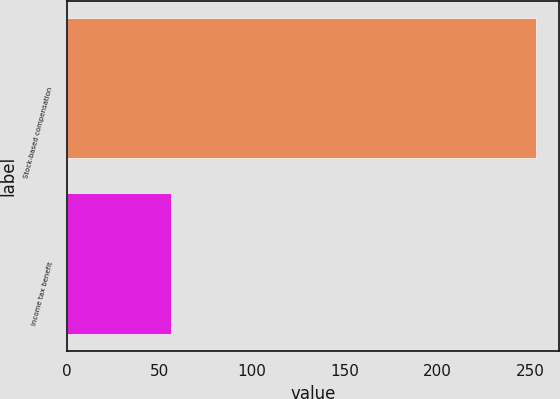Convert chart. <chart><loc_0><loc_0><loc_500><loc_500><bar_chart><fcel>Stock-based compensation<fcel>Income tax benefit<nl><fcel>253<fcel>56<nl></chart> 